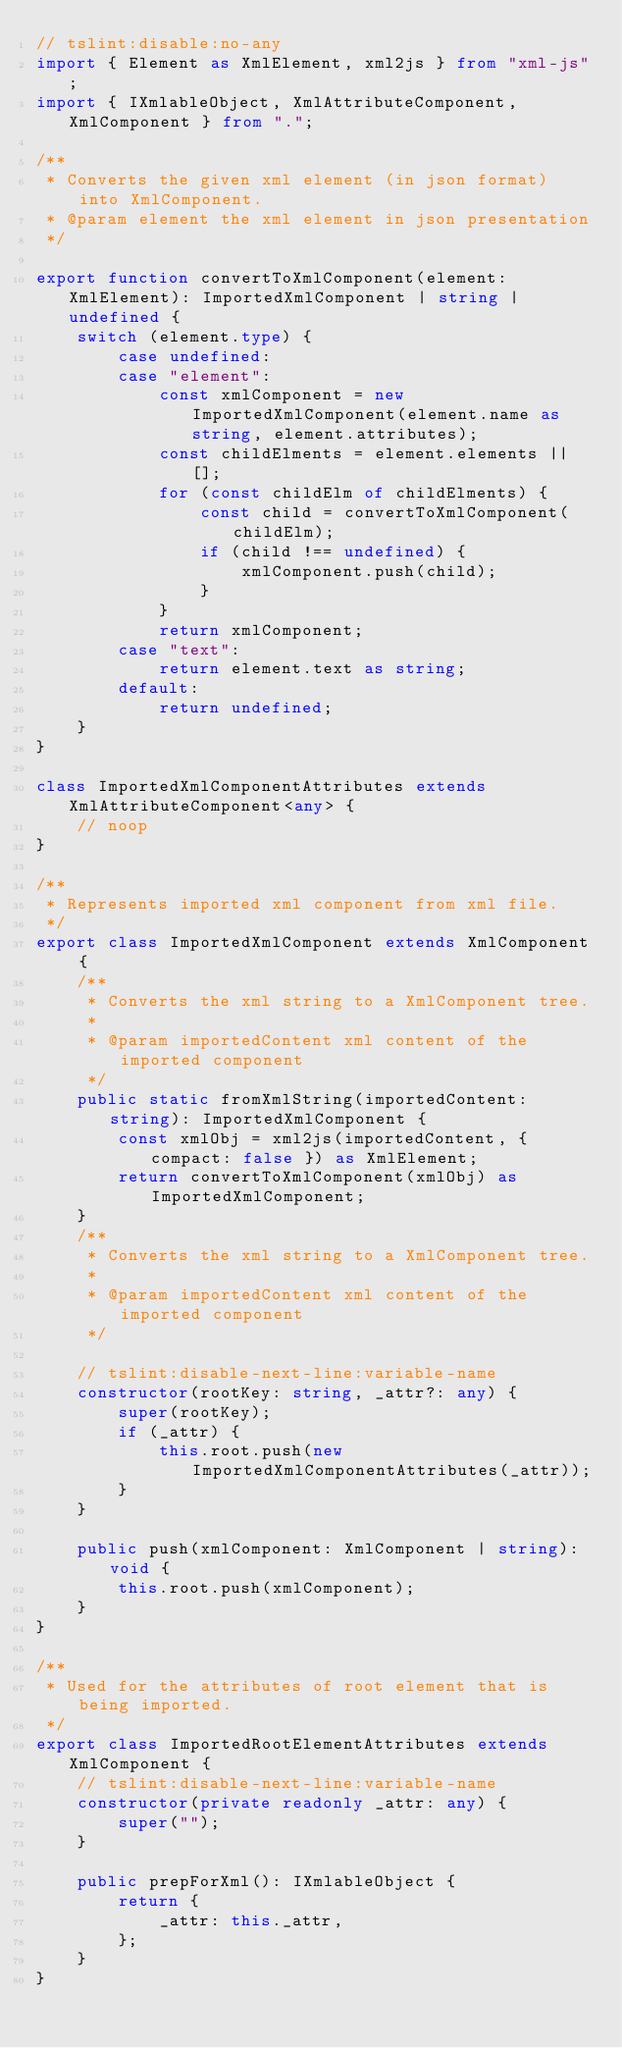Convert code to text. <code><loc_0><loc_0><loc_500><loc_500><_TypeScript_>// tslint:disable:no-any
import { Element as XmlElement, xml2js } from "xml-js";
import { IXmlableObject, XmlAttributeComponent, XmlComponent } from ".";

/**
 * Converts the given xml element (in json format) into XmlComponent.
 * @param element the xml element in json presentation
 */

export function convertToXmlComponent(element: XmlElement): ImportedXmlComponent | string | undefined {
    switch (element.type) {
        case undefined:
        case "element":
            const xmlComponent = new ImportedXmlComponent(element.name as string, element.attributes);
            const childElments = element.elements || [];
            for (const childElm of childElments) {
                const child = convertToXmlComponent(childElm);
                if (child !== undefined) {
                    xmlComponent.push(child);
                }
            }
            return xmlComponent;
        case "text":
            return element.text as string;
        default:
            return undefined;
    }
}

class ImportedXmlComponentAttributes extends XmlAttributeComponent<any> {
    // noop
}

/**
 * Represents imported xml component from xml file.
 */
export class ImportedXmlComponent extends XmlComponent {
    /**
     * Converts the xml string to a XmlComponent tree.
     *
     * @param importedContent xml content of the imported component
     */
    public static fromXmlString(importedContent: string): ImportedXmlComponent {
        const xmlObj = xml2js(importedContent, { compact: false }) as XmlElement;
        return convertToXmlComponent(xmlObj) as ImportedXmlComponent;
    }
    /**
     * Converts the xml string to a XmlComponent tree.
     *
     * @param importedContent xml content of the imported component
     */

    // tslint:disable-next-line:variable-name
    constructor(rootKey: string, _attr?: any) {
        super(rootKey);
        if (_attr) {
            this.root.push(new ImportedXmlComponentAttributes(_attr));
        }
    }

    public push(xmlComponent: XmlComponent | string): void {
        this.root.push(xmlComponent);
    }
}

/**
 * Used for the attributes of root element that is being imported.
 */
export class ImportedRootElementAttributes extends XmlComponent {
    // tslint:disable-next-line:variable-name
    constructor(private readonly _attr: any) {
        super("");
    }

    public prepForXml(): IXmlableObject {
        return {
            _attr: this._attr,
        };
    }
}
</code> 